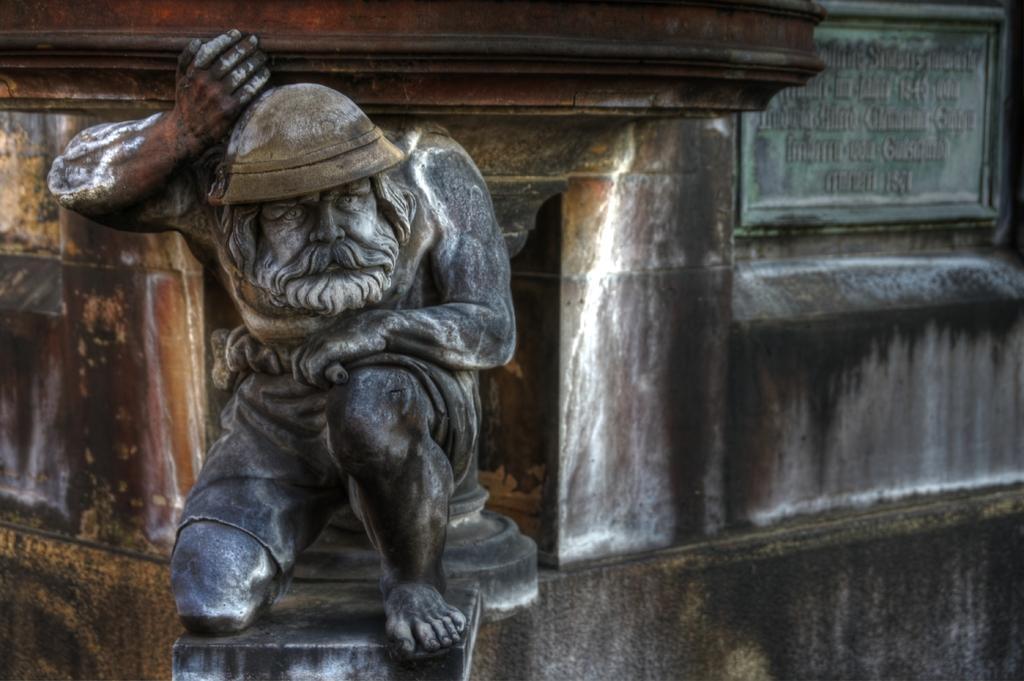How would you summarize this image in a sentence or two? In this picture there is a stone statue of the man. Behind there is a stone naming plate and a huge rock pillar. 